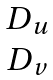Convert formula to latex. <formula><loc_0><loc_0><loc_500><loc_500>\begin{matrix} D _ { u } \\ D _ { v } \end{matrix}</formula> 